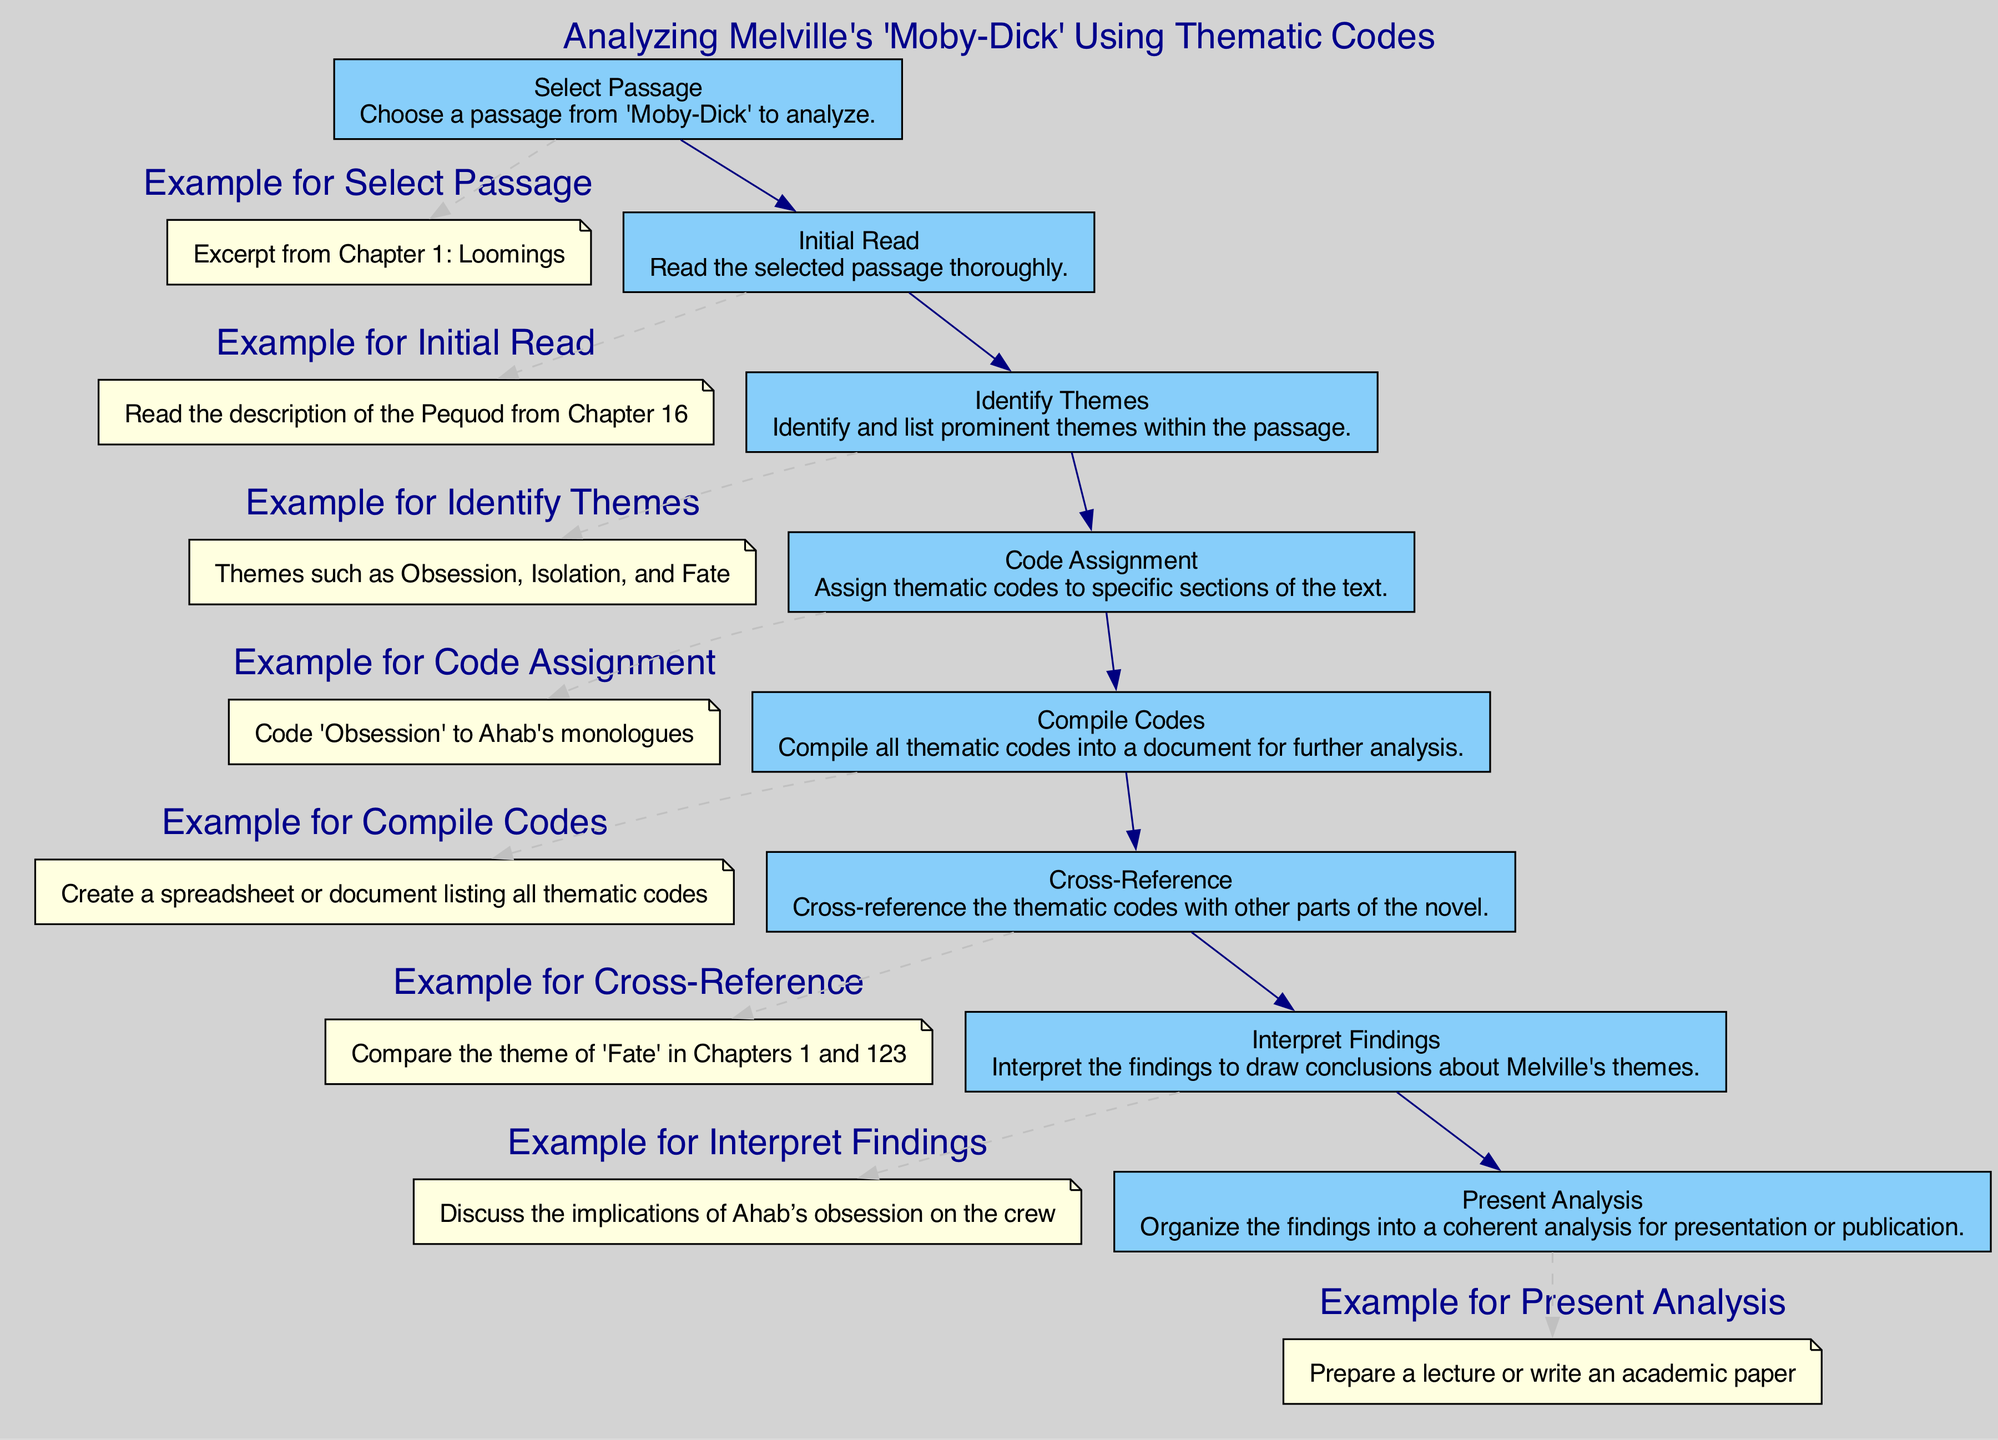What is the first step in the diagram? The first step is to select a passage from 'Moby-Dick' to analyze, as indicated at the top of the flow chart.
Answer: Select Passage How many thematic coding steps are in the diagram? Counting the steps listed in the flow chart, there are a total of eight distinct steps involved in the thematic coding process.
Answer: Eight What step involves comparing codes with other parts of the novel? The step that involves comparing the thematic codes with other parts of the novel is labeled as "Cross-Reference."
Answer: Cross-Reference What step comes after "Identify Themes"? The step that comes directly after "Identify Themes" is "Code Assignment," which follows logically to assign thematic codes.
Answer: Code Assignment What type of output is suggested at the final step? The final step suggests the output type as a coherent analysis for presentation or publication, such as a lecture or academic paper.
Answer: Present Analysis How many examples are provided for each step? Each step has one corresponding example that illustrates the application of the step in the thematic analysis process.
Answer: One What does the subgraph for each step include? Each subgraph for every step includes an example related to that specific step, providing clarity on its application.
Answer: Example What is the last step in the analysis process? The last step in the analysis process is "Present Analysis," which completes the thematic coding task.
Answer: Present Analysis 